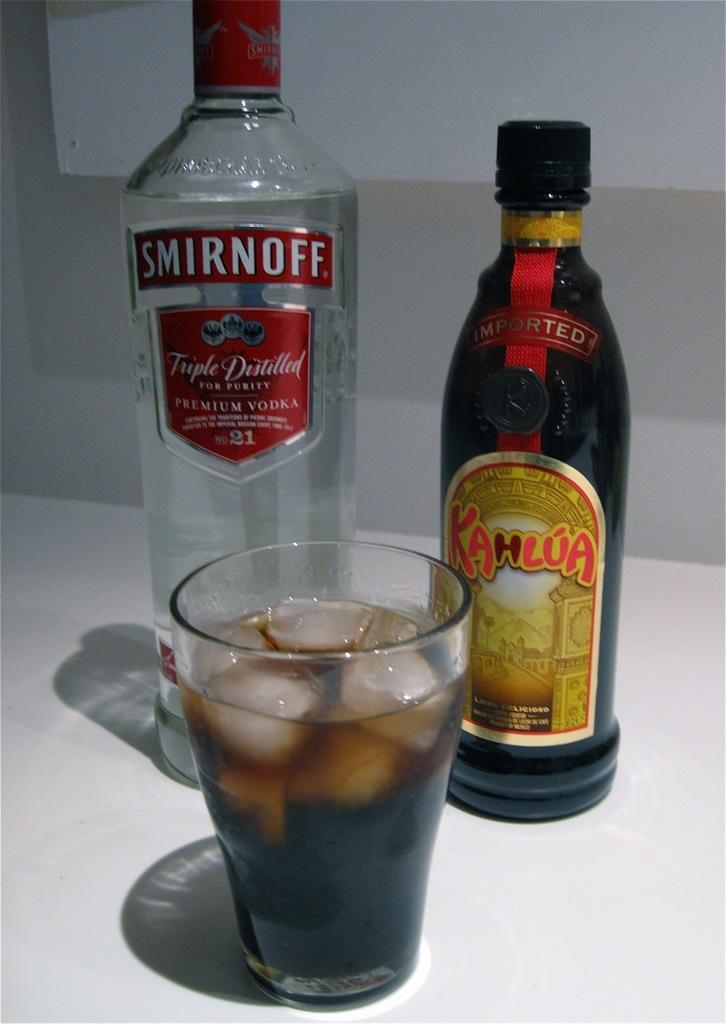<image>
Describe the image concisely. a bottle of smirnoff standing behind a glass of soda and ice 